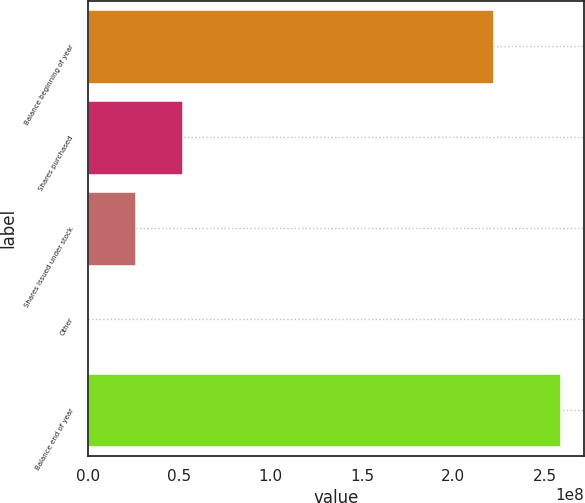<chart> <loc_0><loc_0><loc_500><loc_500><bar_chart><fcel>Balance beginning of year<fcel>Shares purchased<fcel>Shares issued under stock<fcel>Other<fcel>Balance end of year<nl><fcel>2.21743e+08<fcel>5.16861e+07<fcel>2.58508e+07<fcel>15436<fcel>2.58369e+08<nl></chart> 